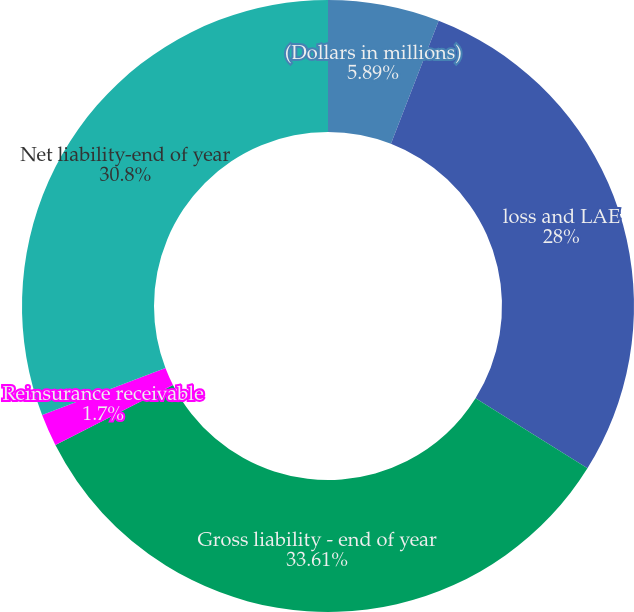<chart> <loc_0><loc_0><loc_500><loc_500><pie_chart><fcel>(Dollars in millions)<fcel>loss and LAE<fcel>Gross liability - end of year<fcel>Reinsurance receivable<fcel>Net liability-end of year<nl><fcel>5.89%<fcel>28.0%<fcel>33.6%<fcel>1.7%<fcel>30.8%<nl></chart> 